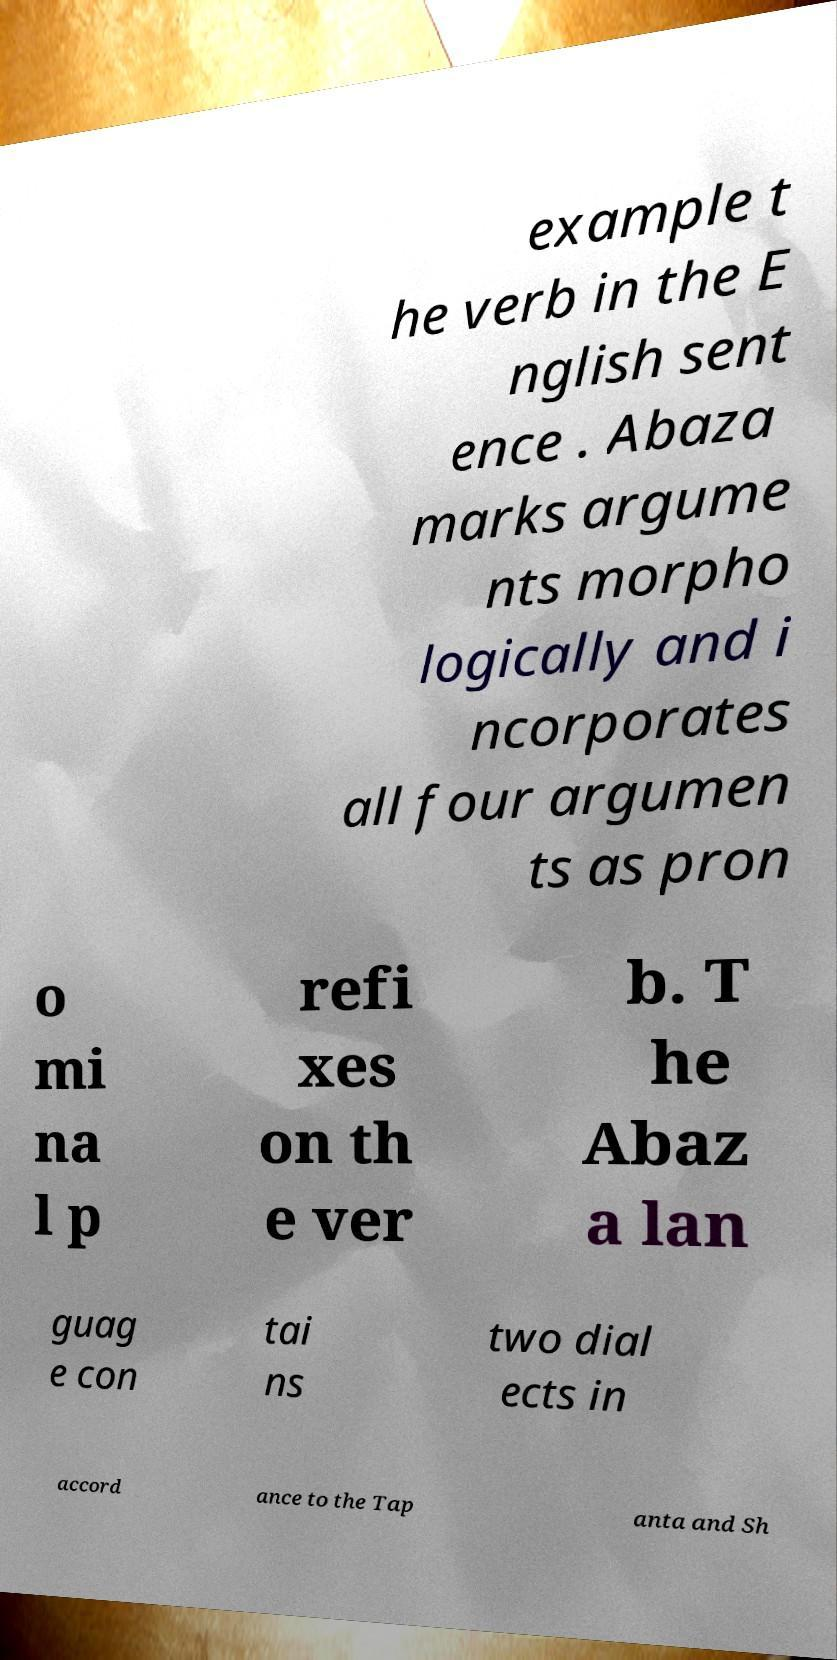Could you assist in decoding the text presented in this image and type it out clearly? example t he verb in the E nglish sent ence . Abaza marks argume nts morpho logically and i ncorporates all four argumen ts as pron o mi na l p refi xes on th e ver b. T he Abaz a lan guag e con tai ns two dial ects in accord ance to the Tap anta and Sh 